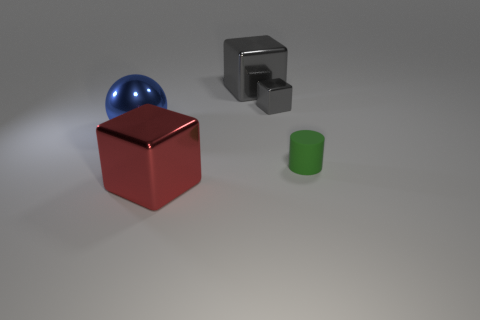What color is the ball that is the same size as the red metal thing?
Offer a terse response. Blue. What number of red objects are tiny matte things or large blocks?
Provide a succinct answer. 1. Is the number of large objects greater than the number of big rubber cylinders?
Make the answer very short. Yes. Do the gray shiny cube right of the large gray metal block and the gray shiny object behind the tiny gray thing have the same size?
Your answer should be compact. No. There is a large cube that is to the left of the large metal object that is right of the shiny cube that is in front of the tiny green rubber thing; what is its color?
Your answer should be very brief. Red. Are there any large brown things that have the same shape as the blue thing?
Give a very brief answer. No. Are there more rubber objects that are on the right side of the green matte cylinder than green cylinders?
Offer a very short reply. No. How many metallic things are either small gray blocks or big gray cubes?
Make the answer very short. 2. There is a object that is in front of the metallic ball and on the right side of the large red metallic cube; what is its size?
Offer a very short reply. Small. Are there any tiny matte cylinders that are in front of the big metallic cube in front of the blue shiny ball?
Offer a terse response. No. 